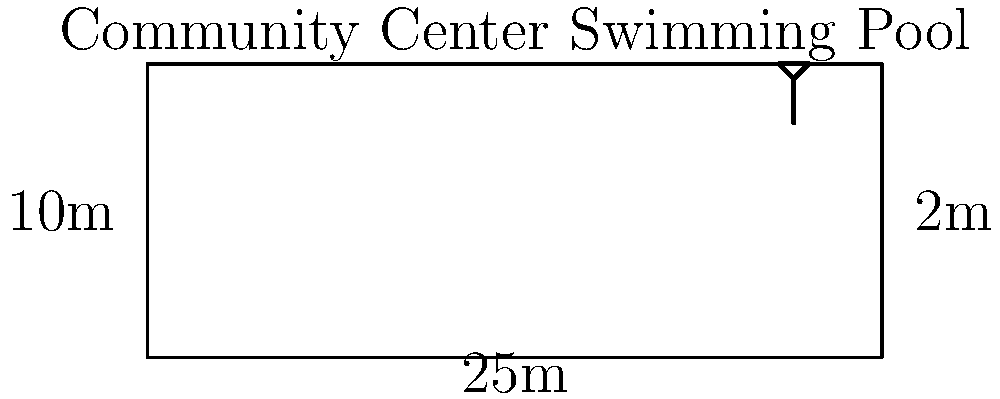The community center's swimming pool measures 25m long, 10m wide, and has an average depth of 2m. If the pool loses 5% of its water volume daily due to evaporation and splashing, and needs to be refilled when it loses 15% of its total volume, how many days can the pool operate before requiring a refill? Round your answer to the nearest whole day. To solve this problem, let's follow these steps:

1) Calculate the total volume of the pool:
   $V = length \times width \times depth$
   $V = 25m \times 10m \times 2m = 500m^3$

2) Calculate 15% of the total volume (the point at which the pool needs refilling):
   $15\% \text{ of } 500m^3 = 0.15 \times 500m^3 = 75m^3$

3) Calculate the daily water loss:
   $5\% \text{ of } 500m^3 = 0.05 \times 500m^3 = 25m^3 \text{ per day}$

4) Calculate how many days it takes to lose 75m^3:
   $\text{Number of days} = \frac{\text{Volume to lose}}{\text{Daily loss}}$
   $\text{Number of days} = \frac{75m^3}{25m^3/day} = 3 \text{ days}$

Therefore, the pool can operate for 3 days before requiring a refill.
Answer: 3 days 